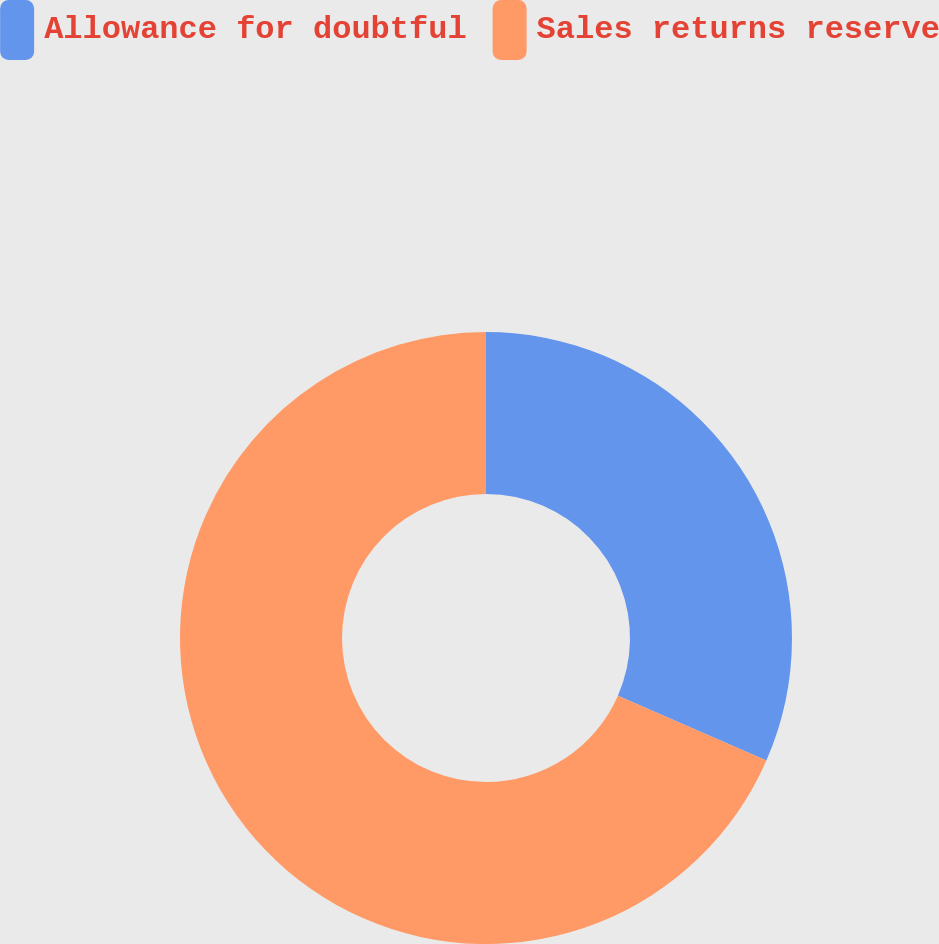<chart> <loc_0><loc_0><loc_500><loc_500><pie_chart><fcel>Allowance for doubtful<fcel>Sales returns reserve<nl><fcel>31.56%<fcel>68.44%<nl></chart> 